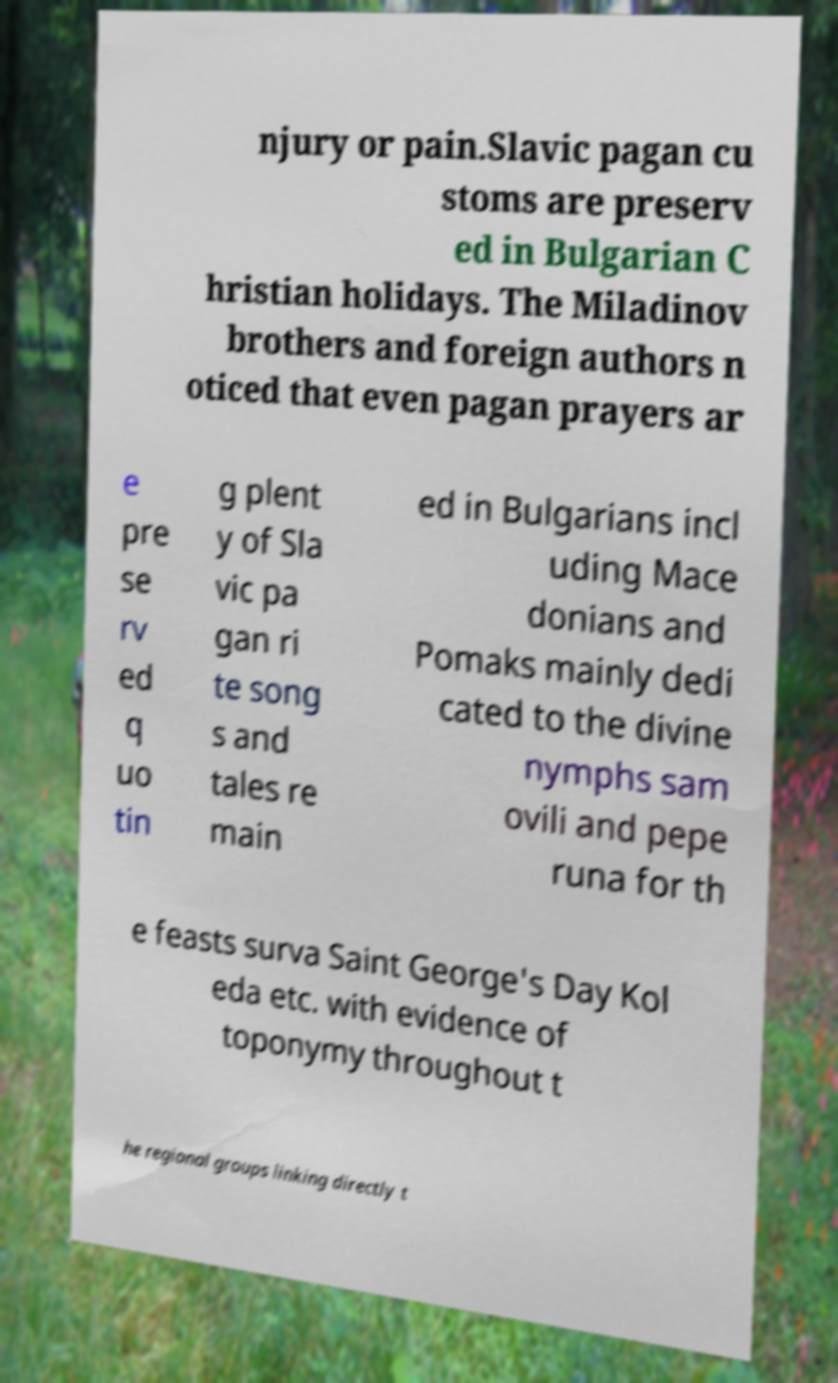For documentation purposes, I need the text within this image transcribed. Could you provide that? njury or pain.Slavic pagan cu stoms are preserv ed in Bulgarian C hristian holidays. The Miladinov brothers and foreign authors n oticed that even pagan prayers ar e pre se rv ed q uo tin g plent y of Sla vic pa gan ri te song s and tales re main ed in Bulgarians incl uding Mace donians and Pomaks mainly dedi cated to the divine nymphs sam ovili and pepe runa for th e feasts surva Saint George's Day Kol eda etc. with evidence of toponymy throughout t he regional groups linking directly t 